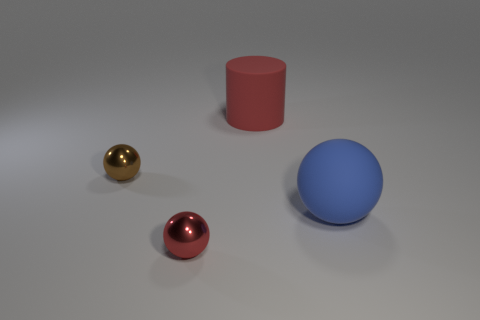Is the brown sphere made of the same material as the big red thing that is behind the red metal thing?
Provide a short and direct response. No. There is a thing that is in front of the red cylinder and behind the big rubber ball; what is its material?
Offer a terse response. Metal. What color is the matte thing that is left of the large thing that is in front of the big red object?
Ensure brevity in your answer.  Red. There is a large object that is on the left side of the blue rubber object; what is it made of?
Your answer should be compact. Rubber. Is the number of small gray metallic cylinders less than the number of large blue things?
Your answer should be very brief. Yes. Do the small brown metal object and the red thing in front of the large blue thing have the same shape?
Make the answer very short. Yes. What is the shape of the object that is both in front of the small brown thing and to the left of the blue ball?
Ensure brevity in your answer.  Sphere. Is the number of red rubber things that are in front of the tiny red shiny sphere the same as the number of rubber cylinders behind the big red object?
Your answer should be very brief. Yes. There is a small shiny object that is behind the red shiny thing; is it the same shape as the red shiny object?
Give a very brief answer. Yes. What number of brown objects are either tiny rubber spheres or shiny things?
Ensure brevity in your answer.  1. 